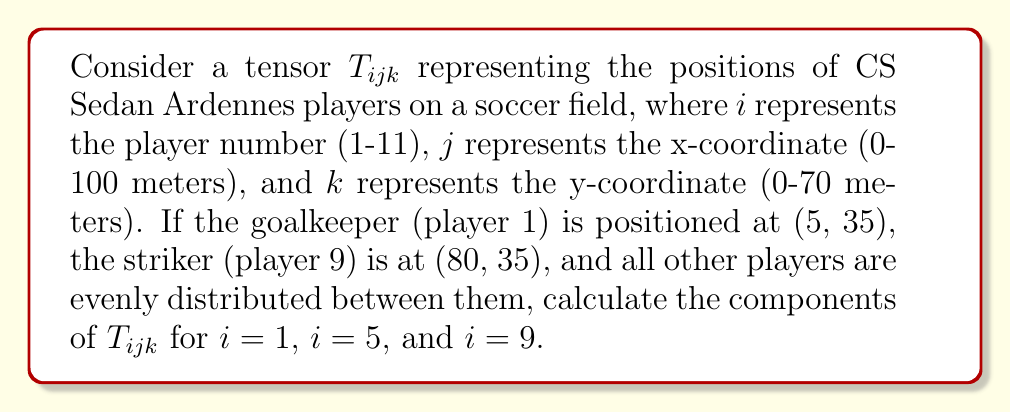Can you solve this math problem? Let's approach this step-by-step:

1) First, we need to understand the structure of the tensor $T_{ijk}$:
   - $i$ represents the player number (1-11)
   - $j$ represents the x-coordinate (0-100 meters)
   - $k$ represents the y-coordinate (0-70 meters)

2) We're given the positions of two players:
   - Goalkeeper (player 1): (5, 35)
   - Striker (player 9): (80, 35)

3) All other players are evenly distributed between these two. To calculate their positions:
   - X-coordinate difference: 80 - 5 = 75 meters
   - Number of intervals between player 1 and 9: 8
   - X-coordinate step: 75 / 8 = 9.375 meters

4) Now we can calculate the positions:
   - Player 1 (Goalkeeper): $T_{1,5,35} = 1$
   - Player 5 (Midfield): x = 5 + 4(9.375) = 42.5
                          $T_{5,42.5,35} = 1$
   - Player 9 (Striker): $T_{9,80,35} = 1$

5) All other components of $T_{ijk}$ for these players are 0.
Answer: $T_{1,5,35} = 1$, $T_{5,42.5,35} = 1$, $T_{9,80,35} = 1$ 